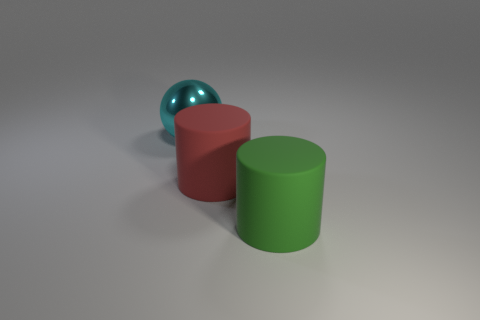Add 1 purple balls. How many objects exist? 4 Subtract all cylinders. How many objects are left? 1 Add 1 small purple cylinders. How many small purple cylinders exist? 1 Subtract 0 green blocks. How many objects are left? 3 Subtract all purple things. Subtract all large red objects. How many objects are left? 2 Add 2 cyan metal objects. How many cyan metal objects are left? 3 